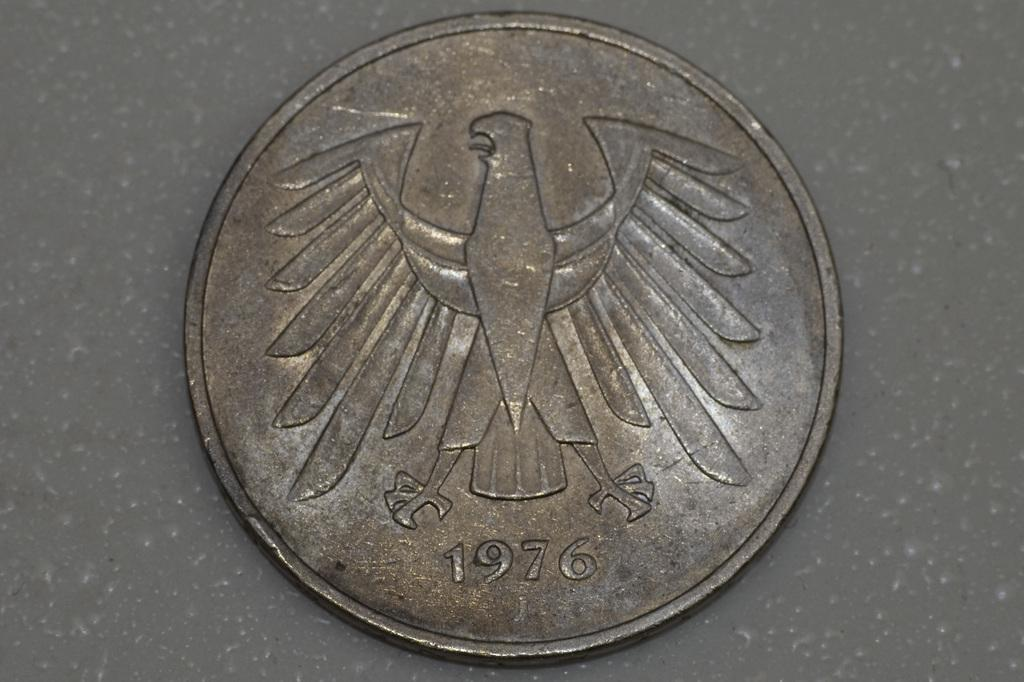<image>
Provide a brief description of the given image. A brown coin with the face of an eagle and date 1976. 